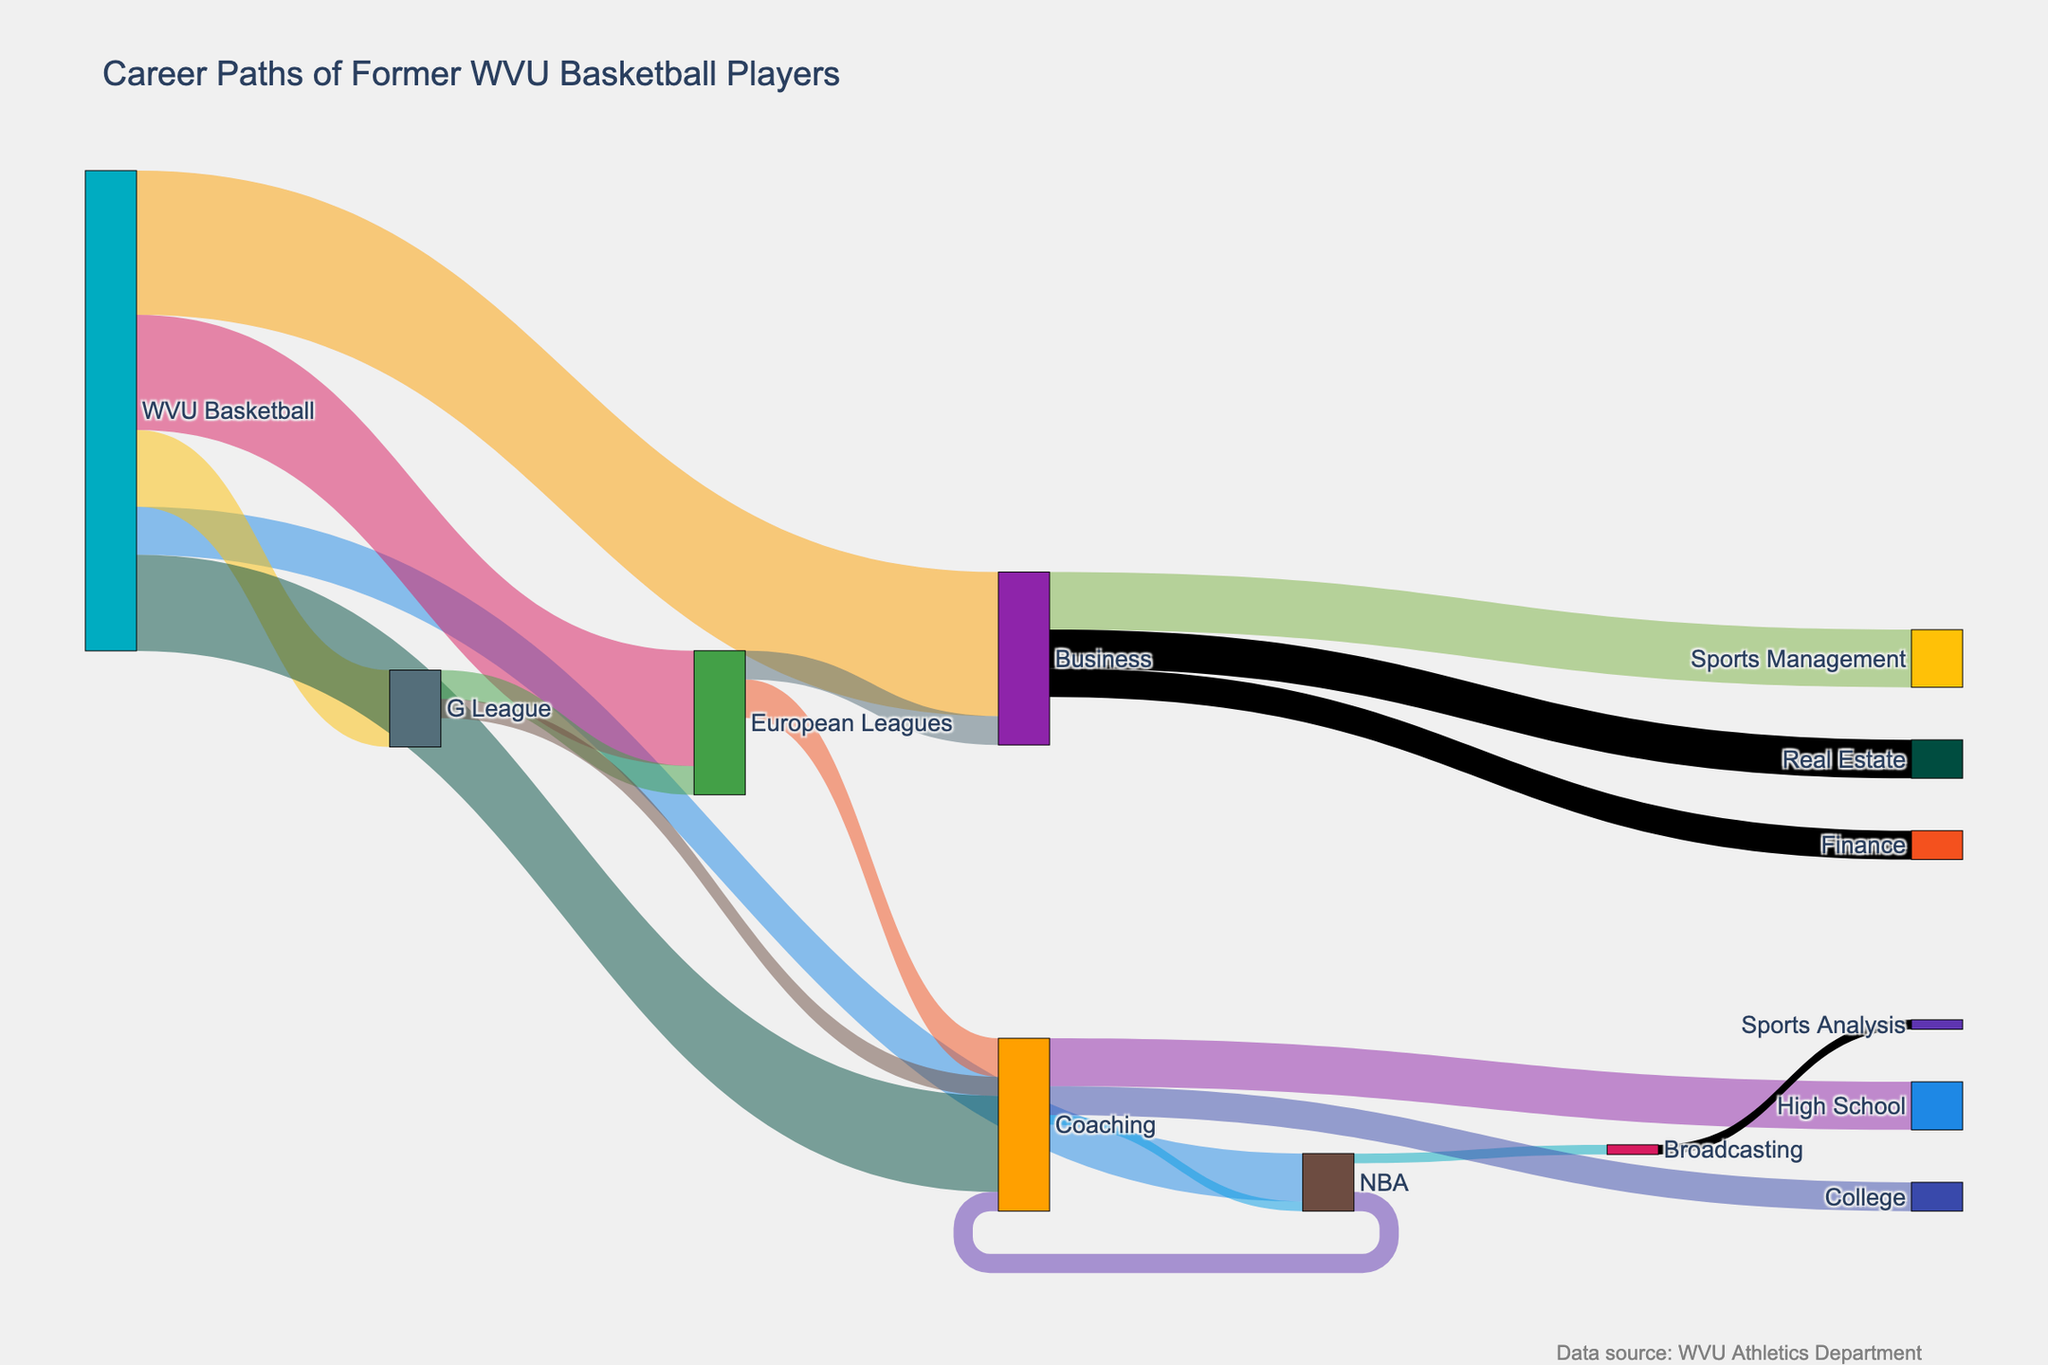What is the title of the figure? The title of the figure is located at the top center and provides a summary of the content depicted. In this case, it says "Career Paths of Former WVU Basketball Players"
Answer: Career Paths of Former WVU Basketball Players Which career path has the highest number of former WVU basketball players after graduation? By examining the width of the links originating from "WVU Basketball," we can identify that the path with the widest link corresponds to the career with the highest number of former players. "Business" has the highest value of 15.
Answer: Business How many former WVU basketball players joined the NBA directly after graduation? Look for the link leading from "WVU Basketball" to "NBA" and note its value, which is labeled as 5.
Answer: 5 Which post-graduation career path has more players: European Leagues or the G League? Compare the values of the links between "WVU Basketball" and both "European Leagues" and "G League." The former has a value of 12, while the latter has a value of 8. Thus, "European Leagues" has more players.
Answer: European Leagues How many different career paths do former WVU basketball players enter after playing in the European Leagues? Observe the branches extending from "European Leagues" and count the distinct target nodes. They lead to "Coaching," "Business," with values 4 and 3 respectively, totaling 2 different paths.
Answer: 2 What's the total number of former WVU basketball players who moved into a coaching career, from all sources? Sum the values of all links leading to "Coaching" from "WVU Basketball" (10), "NBA" (2), "G League" (2), and "European Leagues" (4). The sum is 10 + 2 + 2 + 4 = 18.
Answer: 18 Do more former players from the coaching path end up in High School or College coaching? Compare the values of the links from "Coaching" to "High School" (5) and to "College" (3). More players end up in High School coaching.
Answer: High School How many former players shifted from "Business" to "Real Estate" careers? Find the link that connects "Business" to "Real Estate" and note its value, which is labeled as 4.
Answer: 4 Which secondary career path has only a single former player transitioning to it? Locate the target nodes with a value of 1; these are "Broadcasting" from "NBA" and "Sports Analysis" from "Broadcasting."
Answer: Broadcasting, Sports Analysis 